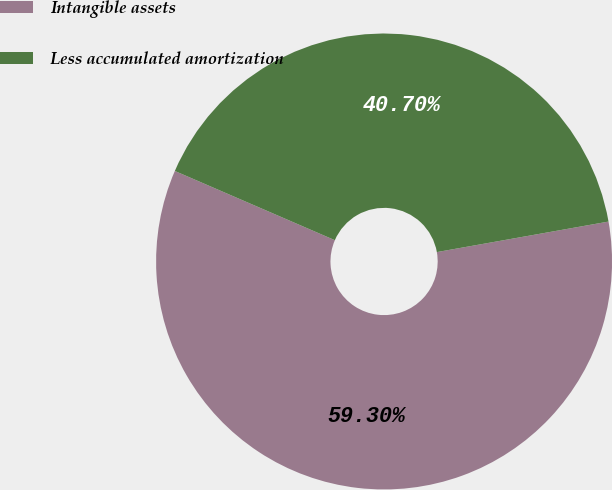Convert chart to OTSL. <chart><loc_0><loc_0><loc_500><loc_500><pie_chart><fcel>Intangible assets<fcel>Less accumulated amortization<nl><fcel>59.3%<fcel>40.7%<nl></chart> 